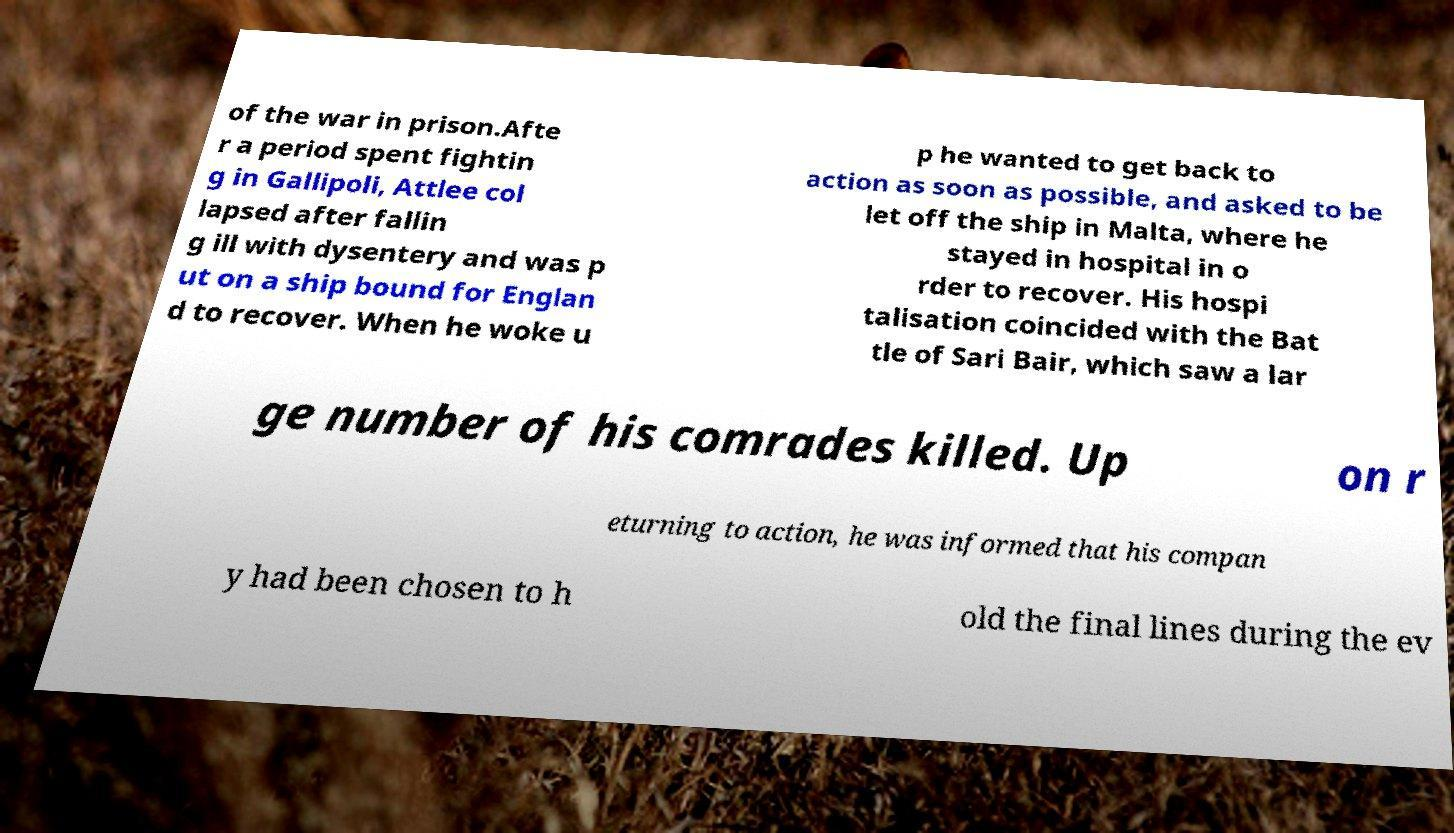There's text embedded in this image that I need extracted. Can you transcribe it verbatim? of the war in prison.Afte r a period spent fightin g in Gallipoli, Attlee col lapsed after fallin g ill with dysentery and was p ut on a ship bound for Englan d to recover. When he woke u p he wanted to get back to action as soon as possible, and asked to be let off the ship in Malta, where he stayed in hospital in o rder to recover. His hospi talisation coincided with the Bat tle of Sari Bair, which saw a lar ge number of his comrades killed. Up on r eturning to action, he was informed that his compan y had been chosen to h old the final lines during the ev 